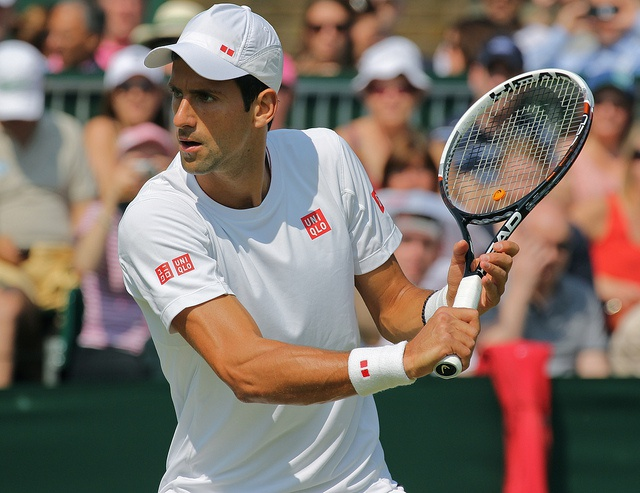Describe the objects in this image and their specific colors. I can see people in darkgray, lightgray, maroon, and tan tones, people in darkgray, tan, and gray tones, tennis racket in darkgray, black, and gray tones, people in darkgray, gray, and black tones, and people in darkgray, salmon, maroon, and lightgray tones in this image. 